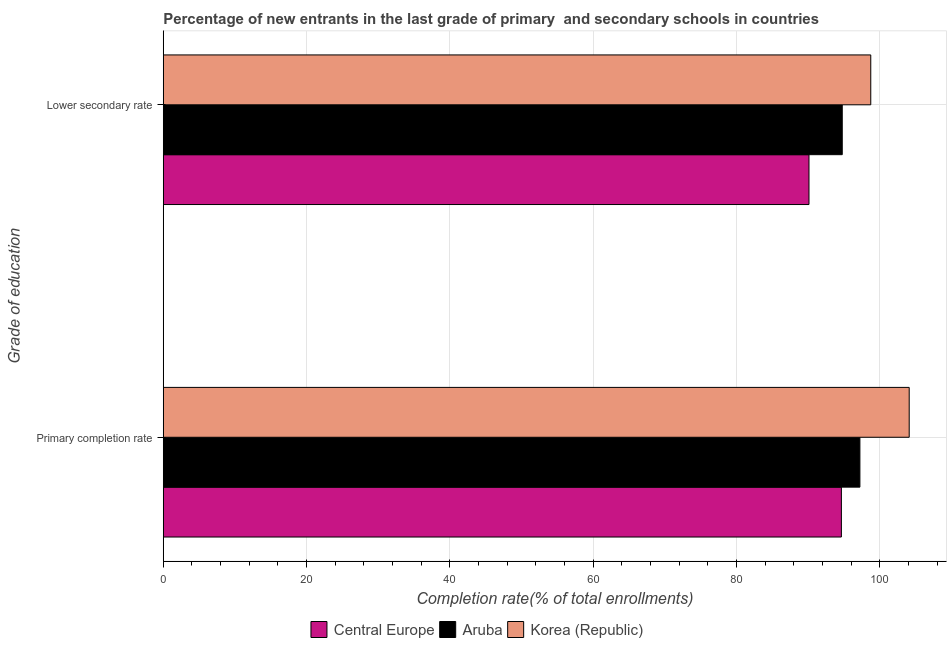Are the number of bars on each tick of the Y-axis equal?
Your answer should be compact. Yes. How many bars are there on the 2nd tick from the top?
Keep it short and to the point. 3. How many bars are there on the 2nd tick from the bottom?
Provide a short and direct response. 3. What is the label of the 1st group of bars from the top?
Keep it short and to the point. Lower secondary rate. What is the completion rate in secondary schools in Central Europe?
Offer a very short reply. 90.11. Across all countries, what is the maximum completion rate in primary schools?
Make the answer very short. 104.1. Across all countries, what is the minimum completion rate in primary schools?
Offer a terse response. 94.63. In which country was the completion rate in secondary schools minimum?
Your answer should be very brief. Central Europe. What is the total completion rate in secondary schools in the graph?
Offer a very short reply. 283.6. What is the difference between the completion rate in primary schools in Korea (Republic) and that in Aruba?
Give a very brief answer. 6.88. What is the difference between the completion rate in primary schools in Aruba and the completion rate in secondary schools in Korea (Republic)?
Your answer should be compact. -1.52. What is the average completion rate in secondary schools per country?
Your response must be concise. 94.53. What is the difference between the completion rate in secondary schools and completion rate in primary schools in Central Europe?
Offer a very short reply. -4.52. In how many countries, is the completion rate in primary schools greater than 32 %?
Keep it short and to the point. 3. What is the ratio of the completion rate in primary schools in Korea (Republic) to that in Aruba?
Keep it short and to the point. 1.07. In how many countries, is the completion rate in primary schools greater than the average completion rate in primary schools taken over all countries?
Your answer should be very brief. 1. What does the 3rd bar from the top in Lower secondary rate represents?
Your response must be concise. Central Europe. Does the graph contain any zero values?
Offer a terse response. No. What is the title of the graph?
Your answer should be compact. Percentage of new entrants in the last grade of primary  and secondary schools in countries. What is the label or title of the X-axis?
Your response must be concise. Completion rate(% of total enrollments). What is the label or title of the Y-axis?
Ensure brevity in your answer.  Grade of education. What is the Completion rate(% of total enrollments) in Central Europe in Primary completion rate?
Your response must be concise. 94.63. What is the Completion rate(% of total enrollments) of Aruba in Primary completion rate?
Provide a short and direct response. 97.22. What is the Completion rate(% of total enrollments) of Korea (Republic) in Primary completion rate?
Ensure brevity in your answer.  104.1. What is the Completion rate(% of total enrollments) in Central Europe in Lower secondary rate?
Keep it short and to the point. 90.11. What is the Completion rate(% of total enrollments) in Aruba in Lower secondary rate?
Your answer should be compact. 94.75. What is the Completion rate(% of total enrollments) in Korea (Republic) in Lower secondary rate?
Ensure brevity in your answer.  98.73. Across all Grade of education, what is the maximum Completion rate(% of total enrollments) of Central Europe?
Provide a succinct answer. 94.63. Across all Grade of education, what is the maximum Completion rate(% of total enrollments) of Aruba?
Your response must be concise. 97.22. Across all Grade of education, what is the maximum Completion rate(% of total enrollments) of Korea (Republic)?
Give a very brief answer. 104.1. Across all Grade of education, what is the minimum Completion rate(% of total enrollments) of Central Europe?
Your answer should be very brief. 90.11. Across all Grade of education, what is the minimum Completion rate(% of total enrollments) in Aruba?
Your response must be concise. 94.75. Across all Grade of education, what is the minimum Completion rate(% of total enrollments) in Korea (Republic)?
Offer a terse response. 98.73. What is the total Completion rate(% of total enrollments) of Central Europe in the graph?
Your answer should be very brief. 184.74. What is the total Completion rate(% of total enrollments) in Aruba in the graph?
Keep it short and to the point. 191.97. What is the total Completion rate(% of total enrollments) of Korea (Republic) in the graph?
Your answer should be very brief. 202.83. What is the difference between the Completion rate(% of total enrollments) in Central Europe in Primary completion rate and that in Lower secondary rate?
Keep it short and to the point. 4.52. What is the difference between the Completion rate(% of total enrollments) of Aruba in Primary completion rate and that in Lower secondary rate?
Your answer should be compact. 2.46. What is the difference between the Completion rate(% of total enrollments) in Korea (Republic) in Primary completion rate and that in Lower secondary rate?
Keep it short and to the point. 5.36. What is the difference between the Completion rate(% of total enrollments) of Central Europe in Primary completion rate and the Completion rate(% of total enrollments) of Aruba in Lower secondary rate?
Provide a succinct answer. -0.12. What is the difference between the Completion rate(% of total enrollments) in Central Europe in Primary completion rate and the Completion rate(% of total enrollments) in Korea (Republic) in Lower secondary rate?
Offer a terse response. -4.1. What is the difference between the Completion rate(% of total enrollments) of Aruba in Primary completion rate and the Completion rate(% of total enrollments) of Korea (Republic) in Lower secondary rate?
Make the answer very short. -1.52. What is the average Completion rate(% of total enrollments) of Central Europe per Grade of education?
Keep it short and to the point. 92.37. What is the average Completion rate(% of total enrollments) in Aruba per Grade of education?
Your response must be concise. 95.98. What is the average Completion rate(% of total enrollments) in Korea (Republic) per Grade of education?
Offer a very short reply. 101.41. What is the difference between the Completion rate(% of total enrollments) of Central Europe and Completion rate(% of total enrollments) of Aruba in Primary completion rate?
Ensure brevity in your answer.  -2.58. What is the difference between the Completion rate(% of total enrollments) in Central Europe and Completion rate(% of total enrollments) in Korea (Republic) in Primary completion rate?
Offer a terse response. -9.46. What is the difference between the Completion rate(% of total enrollments) in Aruba and Completion rate(% of total enrollments) in Korea (Republic) in Primary completion rate?
Ensure brevity in your answer.  -6.88. What is the difference between the Completion rate(% of total enrollments) in Central Europe and Completion rate(% of total enrollments) in Aruba in Lower secondary rate?
Your answer should be very brief. -4.64. What is the difference between the Completion rate(% of total enrollments) of Central Europe and Completion rate(% of total enrollments) of Korea (Republic) in Lower secondary rate?
Your answer should be very brief. -8.62. What is the difference between the Completion rate(% of total enrollments) in Aruba and Completion rate(% of total enrollments) in Korea (Republic) in Lower secondary rate?
Keep it short and to the point. -3.98. What is the ratio of the Completion rate(% of total enrollments) in Central Europe in Primary completion rate to that in Lower secondary rate?
Provide a short and direct response. 1.05. What is the ratio of the Completion rate(% of total enrollments) of Aruba in Primary completion rate to that in Lower secondary rate?
Keep it short and to the point. 1.03. What is the ratio of the Completion rate(% of total enrollments) of Korea (Republic) in Primary completion rate to that in Lower secondary rate?
Keep it short and to the point. 1.05. What is the difference between the highest and the second highest Completion rate(% of total enrollments) in Central Europe?
Give a very brief answer. 4.52. What is the difference between the highest and the second highest Completion rate(% of total enrollments) of Aruba?
Ensure brevity in your answer.  2.46. What is the difference between the highest and the second highest Completion rate(% of total enrollments) of Korea (Republic)?
Provide a short and direct response. 5.36. What is the difference between the highest and the lowest Completion rate(% of total enrollments) of Central Europe?
Provide a succinct answer. 4.52. What is the difference between the highest and the lowest Completion rate(% of total enrollments) of Aruba?
Your response must be concise. 2.46. What is the difference between the highest and the lowest Completion rate(% of total enrollments) of Korea (Republic)?
Make the answer very short. 5.36. 